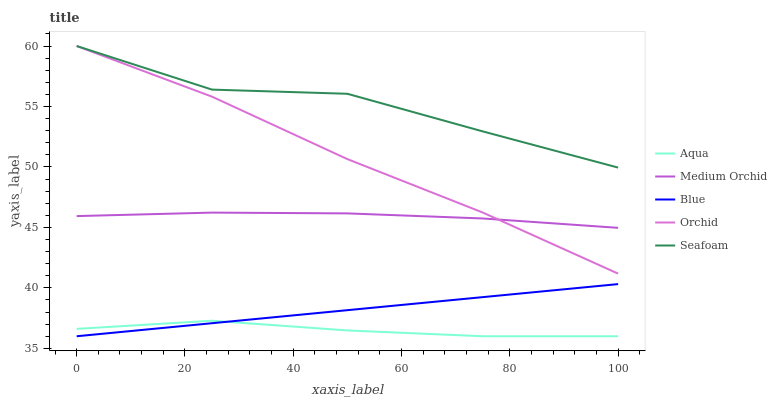Does Aqua have the minimum area under the curve?
Answer yes or no. Yes. Does Seafoam have the maximum area under the curve?
Answer yes or no. Yes. Does Medium Orchid have the minimum area under the curve?
Answer yes or no. No. Does Medium Orchid have the maximum area under the curve?
Answer yes or no. No. Is Blue the smoothest?
Answer yes or no. Yes. Is Seafoam the roughest?
Answer yes or no. Yes. Is Medium Orchid the smoothest?
Answer yes or no. No. Is Medium Orchid the roughest?
Answer yes or no. No. Does Medium Orchid have the lowest value?
Answer yes or no. No. Does Orchid have the highest value?
Answer yes or no. Yes. Does Medium Orchid have the highest value?
Answer yes or no. No. Is Blue less than Medium Orchid?
Answer yes or no. Yes. Is Orchid greater than Aqua?
Answer yes or no. Yes. Does Blue intersect Aqua?
Answer yes or no. Yes. Is Blue less than Aqua?
Answer yes or no. No. Is Blue greater than Aqua?
Answer yes or no. No. Does Blue intersect Medium Orchid?
Answer yes or no. No. 